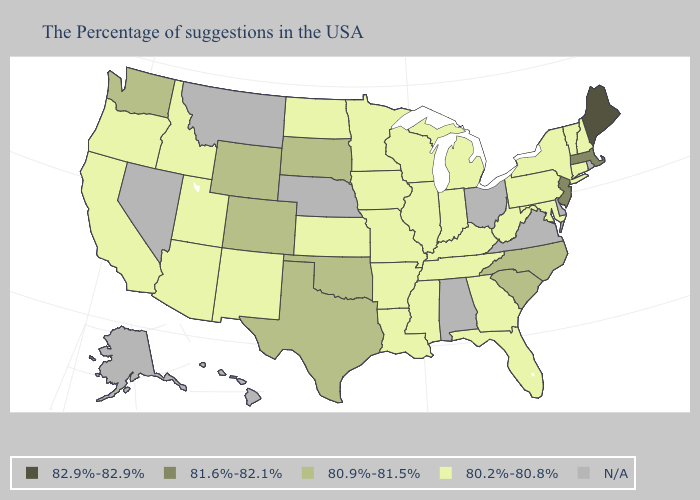Which states have the lowest value in the West?
Keep it brief. New Mexico, Utah, Arizona, Idaho, California, Oregon. What is the lowest value in states that border Washington?
Short answer required. 80.2%-80.8%. Name the states that have a value in the range 81.6%-82.1%?
Give a very brief answer. Massachusetts, New Jersey. Is the legend a continuous bar?
Be succinct. No. Name the states that have a value in the range 80.2%-80.8%?
Answer briefly. New Hampshire, Vermont, Connecticut, New York, Maryland, Pennsylvania, West Virginia, Florida, Georgia, Michigan, Kentucky, Indiana, Tennessee, Wisconsin, Illinois, Mississippi, Louisiana, Missouri, Arkansas, Minnesota, Iowa, Kansas, North Dakota, New Mexico, Utah, Arizona, Idaho, California, Oregon. Does the map have missing data?
Be succinct. Yes. What is the lowest value in the USA?
Be succinct. 80.2%-80.8%. Among the states that border Montana , which have the lowest value?
Keep it brief. North Dakota, Idaho. Name the states that have a value in the range 80.2%-80.8%?
Short answer required. New Hampshire, Vermont, Connecticut, New York, Maryland, Pennsylvania, West Virginia, Florida, Georgia, Michigan, Kentucky, Indiana, Tennessee, Wisconsin, Illinois, Mississippi, Louisiana, Missouri, Arkansas, Minnesota, Iowa, Kansas, North Dakota, New Mexico, Utah, Arizona, Idaho, California, Oregon. What is the lowest value in the South?
Quick response, please. 80.2%-80.8%. Which states have the lowest value in the West?
Keep it brief. New Mexico, Utah, Arizona, Idaho, California, Oregon. Name the states that have a value in the range 82.9%-82.9%?
Answer briefly. Maine. Among the states that border Kansas , does Colorado have the highest value?
Answer briefly. Yes. What is the value of Hawaii?
Be succinct. N/A. 